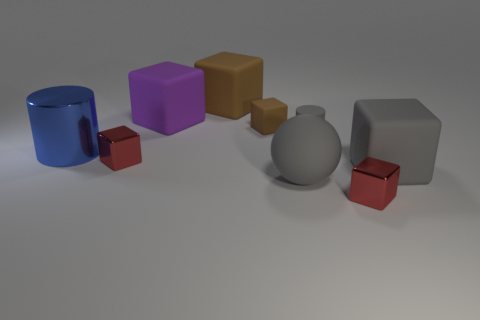Subtract all small rubber cubes. How many cubes are left? 5 Subtract all purple cubes. How many cubes are left? 5 Subtract 0 brown cylinders. How many objects are left? 9 Subtract all cylinders. How many objects are left? 7 Subtract 4 cubes. How many cubes are left? 2 Subtract all brown blocks. Subtract all purple cylinders. How many blocks are left? 4 Subtract all brown cubes. How many red cylinders are left? 0 Subtract all tiny brown rubber blocks. Subtract all big rubber spheres. How many objects are left? 7 Add 5 purple blocks. How many purple blocks are left? 6 Add 7 large purple metallic objects. How many large purple metallic objects exist? 7 